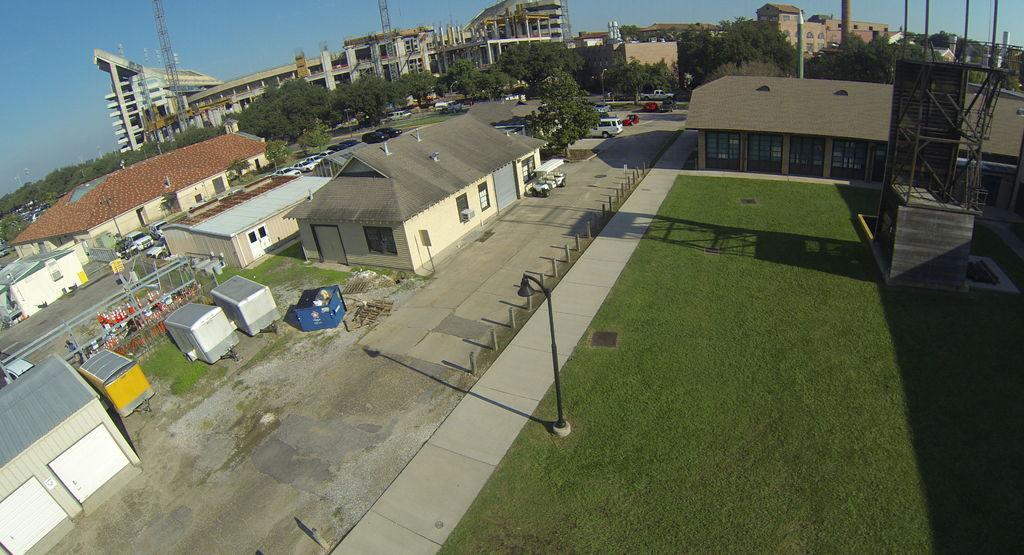Can you describe this image briefly? On the right side of the picture there are trees, buildings, poles, grass, street light and other objects. In the center of the picture there are trees, buildings, cars, road and other objects. On the right there are buildings, roads, vehicles, trees, iron objects and compartments. 